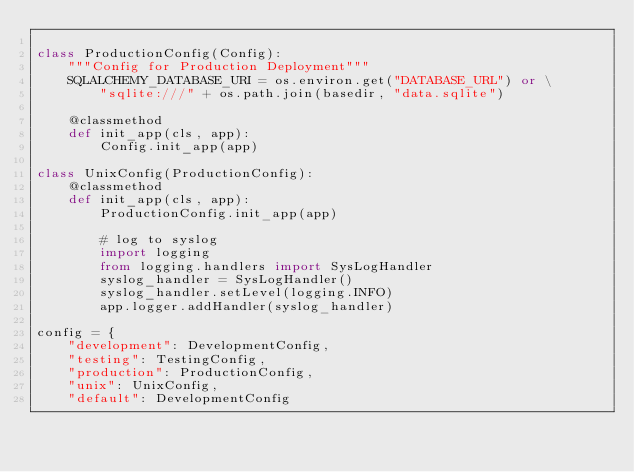<code> <loc_0><loc_0><loc_500><loc_500><_Python_>
class ProductionConfig(Config):
    """Config for Production Deployment"""
    SQLALCHEMY_DATABASE_URI = os.environ.get("DATABASE_URL") or \
        "sqlite:///" + os.path.join(basedir, "data.sqlite")

    @classmethod
    def init_app(cls, app):
        Config.init_app(app)

class UnixConfig(ProductionConfig):
    @classmethod
    def init_app(cls, app):
        ProductionConfig.init_app(app)

        # log to syslog
        import logging
        from logging.handlers import SysLogHandler
        syslog_handler = SysLogHandler()
        syslog_handler.setLevel(logging.INFO)
        app.logger.addHandler(syslog_handler)

config = {
    "development": DevelopmentConfig,
    "testing": TestingConfig,
    "production": ProductionConfig,
    "unix": UnixConfig,
    "default": DevelopmentConfig</code> 